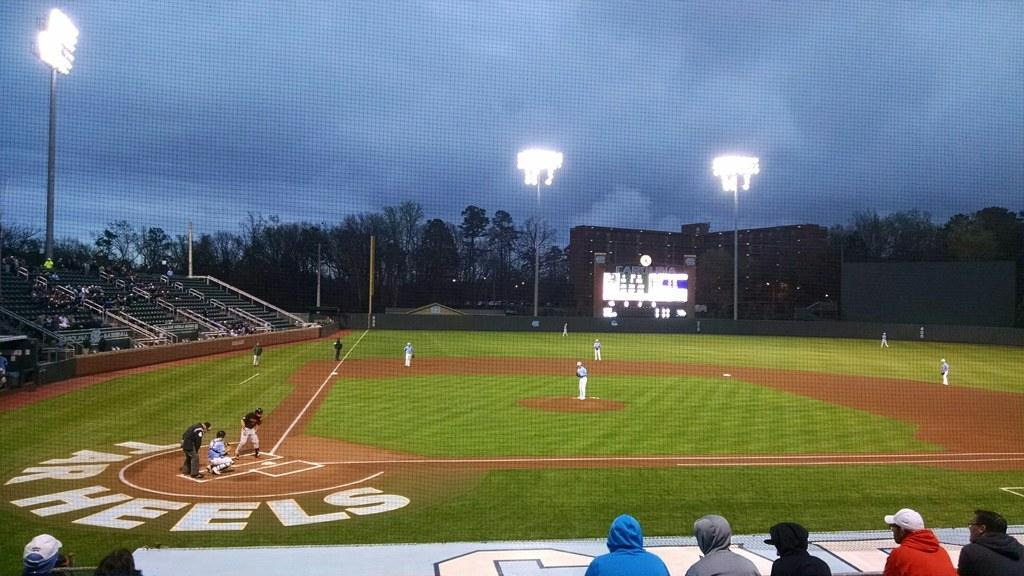Provide a one-sentence caption for the provided image. cloudy day at baseball game where the Tarwheels play. 